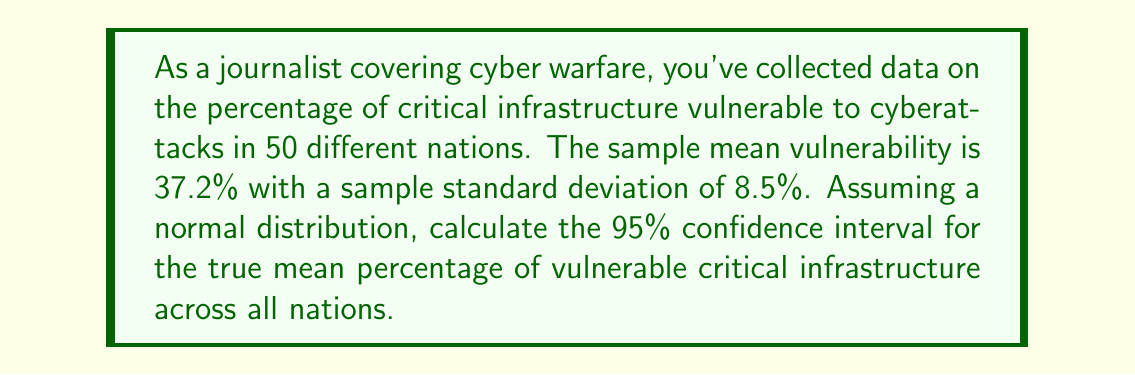Can you answer this question? To calculate the confidence interval, we'll follow these steps:

1) The formula for the confidence interval is:

   $$ \bar{x} \pm t_{\alpha/2} \cdot \frac{s}{\sqrt{n}} $$

   Where:
   $\bar{x}$ is the sample mean
   $t_{\alpha/2}$ is the t-value for the desired confidence level
   $s$ is the sample standard deviation
   $n$ is the sample size

2) We know:
   $\bar{x} = 37.2\%$
   $s = 8.5\%$
   $n = 50$
   Confidence level = 95%, so $\alpha = 0.05$

3) For a 95% confidence interval with 49 degrees of freedom (n-1), the t-value is approximately 2.009 (from t-distribution table).

4) Plugging into the formula:

   $$ 37.2\% \pm 2.009 \cdot \frac{8.5\%}{\sqrt{50}} $$

5) Simplify:
   $$ 37.2\% \pm 2.009 \cdot 1.202\% $$
   $$ 37.2\% \pm 2.415\% $$

6) Therefore, the confidence interval is:
   $$ (37.2\% - 2.415\%, 37.2\% + 2.415\%) $$
   $$ (34.785\%, 39.615\%) $$
Answer: (34.79%, 39.62%) 